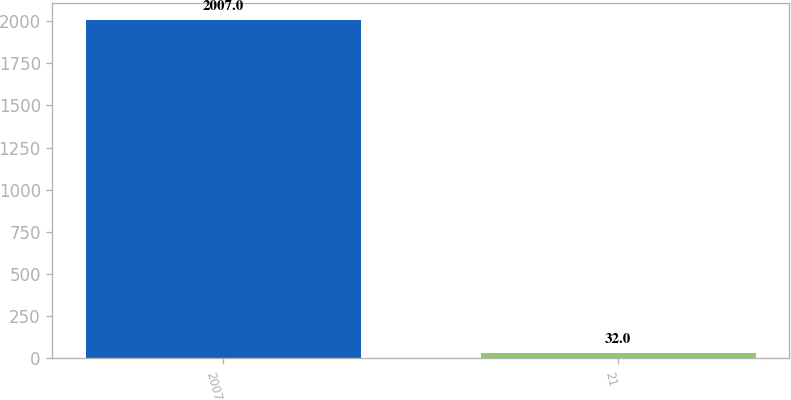Convert chart. <chart><loc_0><loc_0><loc_500><loc_500><bar_chart><fcel>2007<fcel>21<nl><fcel>2007<fcel>32<nl></chart> 